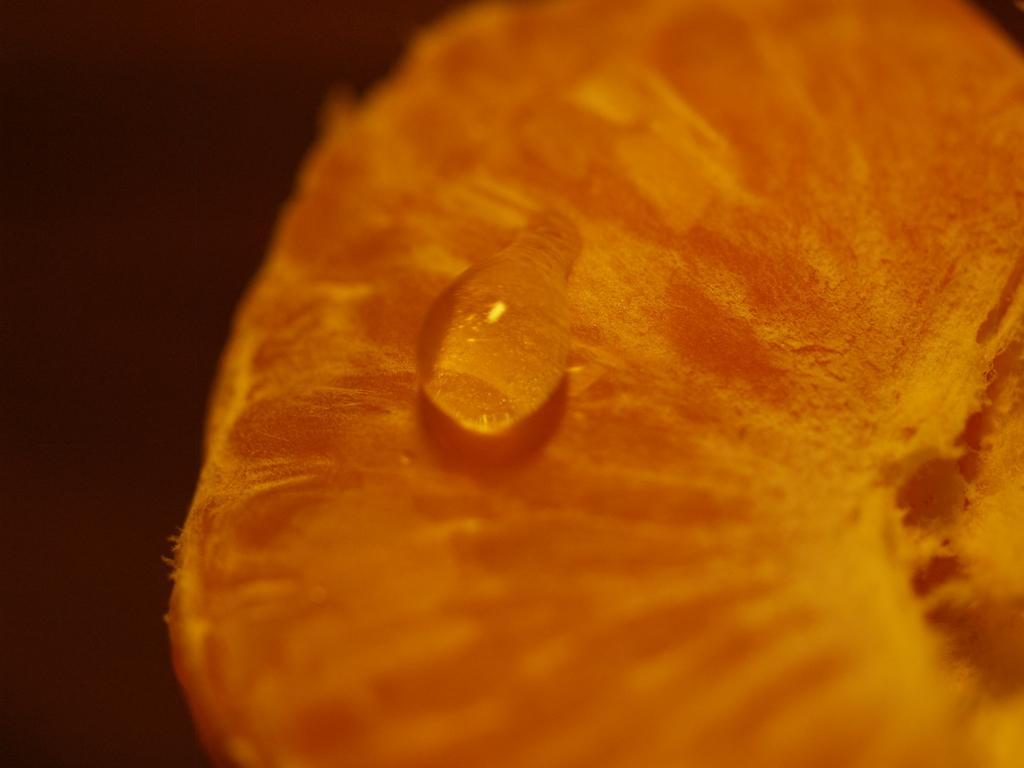Please provide a concise description of this image. In this picture there is a water drop on an orange slice. 